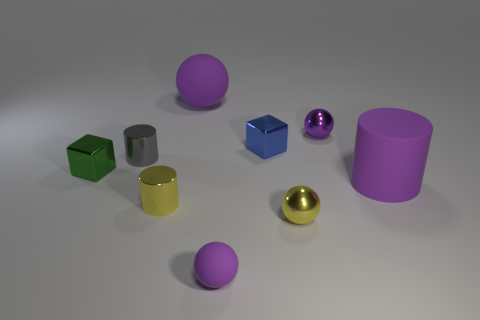Subtract all yellow shiny cylinders. How many cylinders are left? 2 Add 1 big cyan matte cubes. How many objects exist? 10 Subtract all gray cubes. How many purple balls are left? 3 Subtract all green cubes. How many cubes are left? 1 Subtract 4 spheres. How many spheres are left? 0 Subtract all cylinders. How many objects are left? 6 Subtract all red blocks. Subtract all brown cylinders. How many blocks are left? 2 Subtract all gray blocks. Subtract all big matte objects. How many objects are left? 7 Add 1 small yellow balls. How many small yellow balls are left? 2 Add 4 big rubber cylinders. How many big rubber cylinders exist? 5 